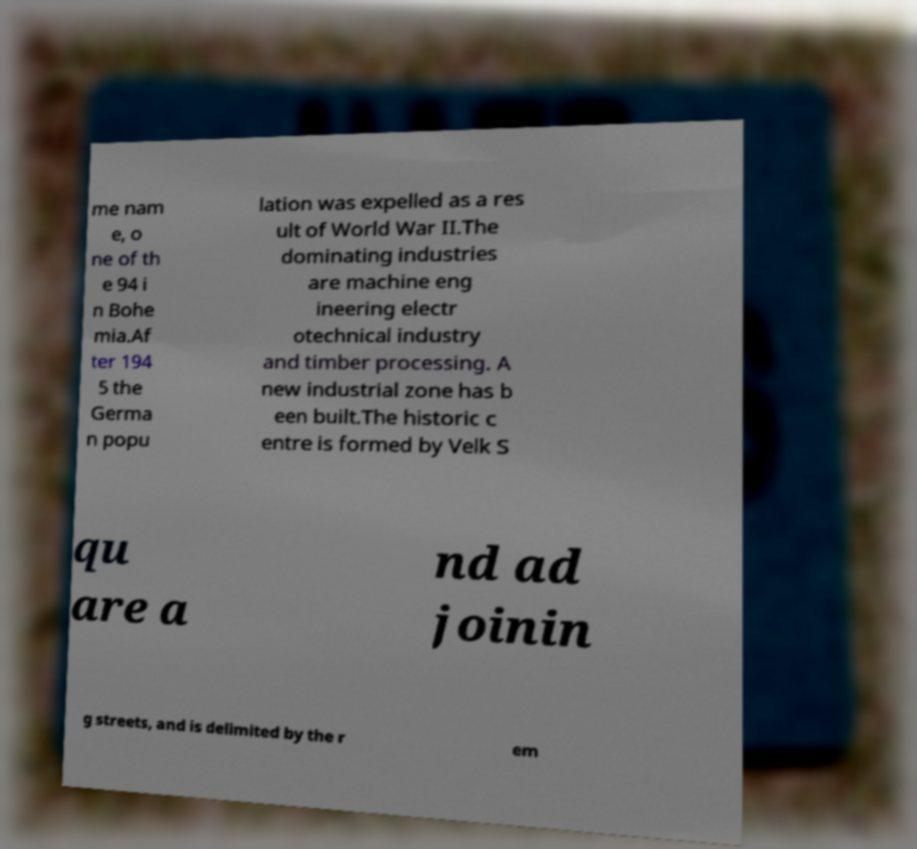Could you assist in decoding the text presented in this image and type it out clearly? me nam e, o ne of th e 94 i n Bohe mia.Af ter 194 5 the Germa n popu lation was expelled as a res ult of World War II.The dominating industries are machine eng ineering electr otechnical industry and timber processing. A new industrial zone has b een built.The historic c entre is formed by Velk S qu are a nd ad joinin g streets, and is delimited by the r em 